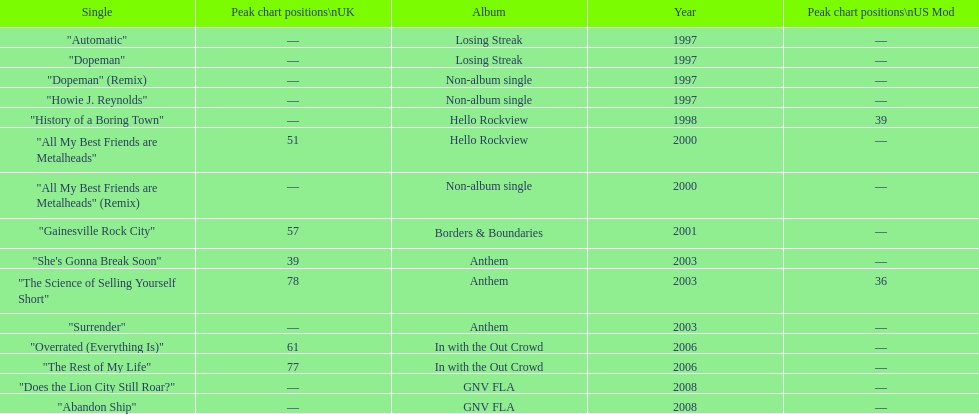How long was it between losing streak almbum and gnv fla in years. 11. 